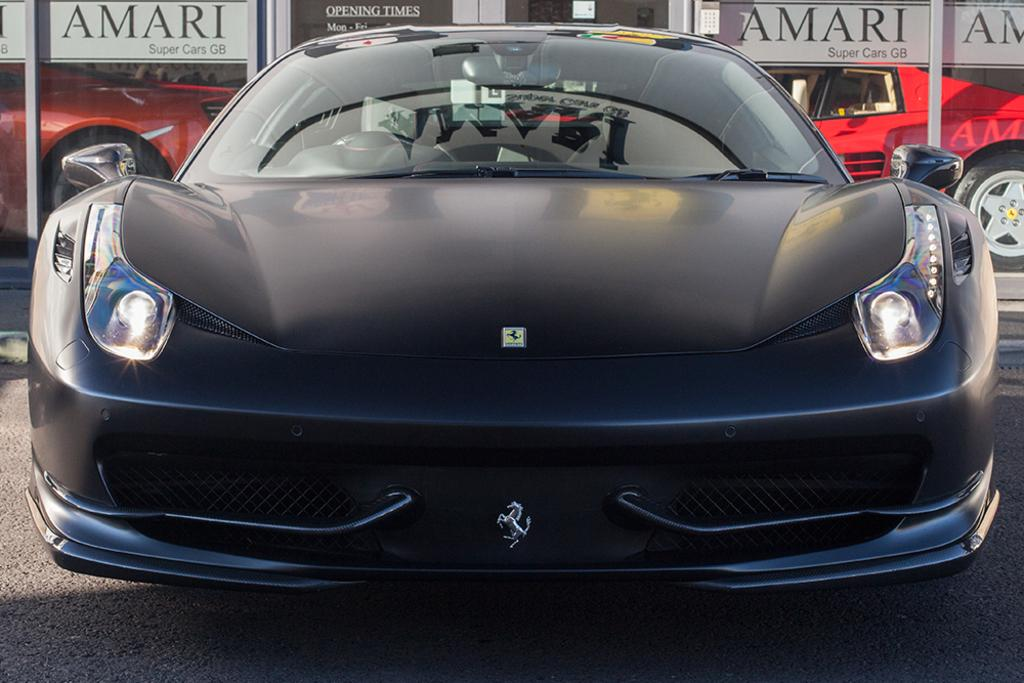What is the main subject of the image? There is a car in the center of the image. Can you describe the surrounding environment in the image? There are other cars in the background of the image. What type of pancake is being served at the restaurant in the image? There is no restaurant or pancake present in the image; it only features a car and other cars in the background. 